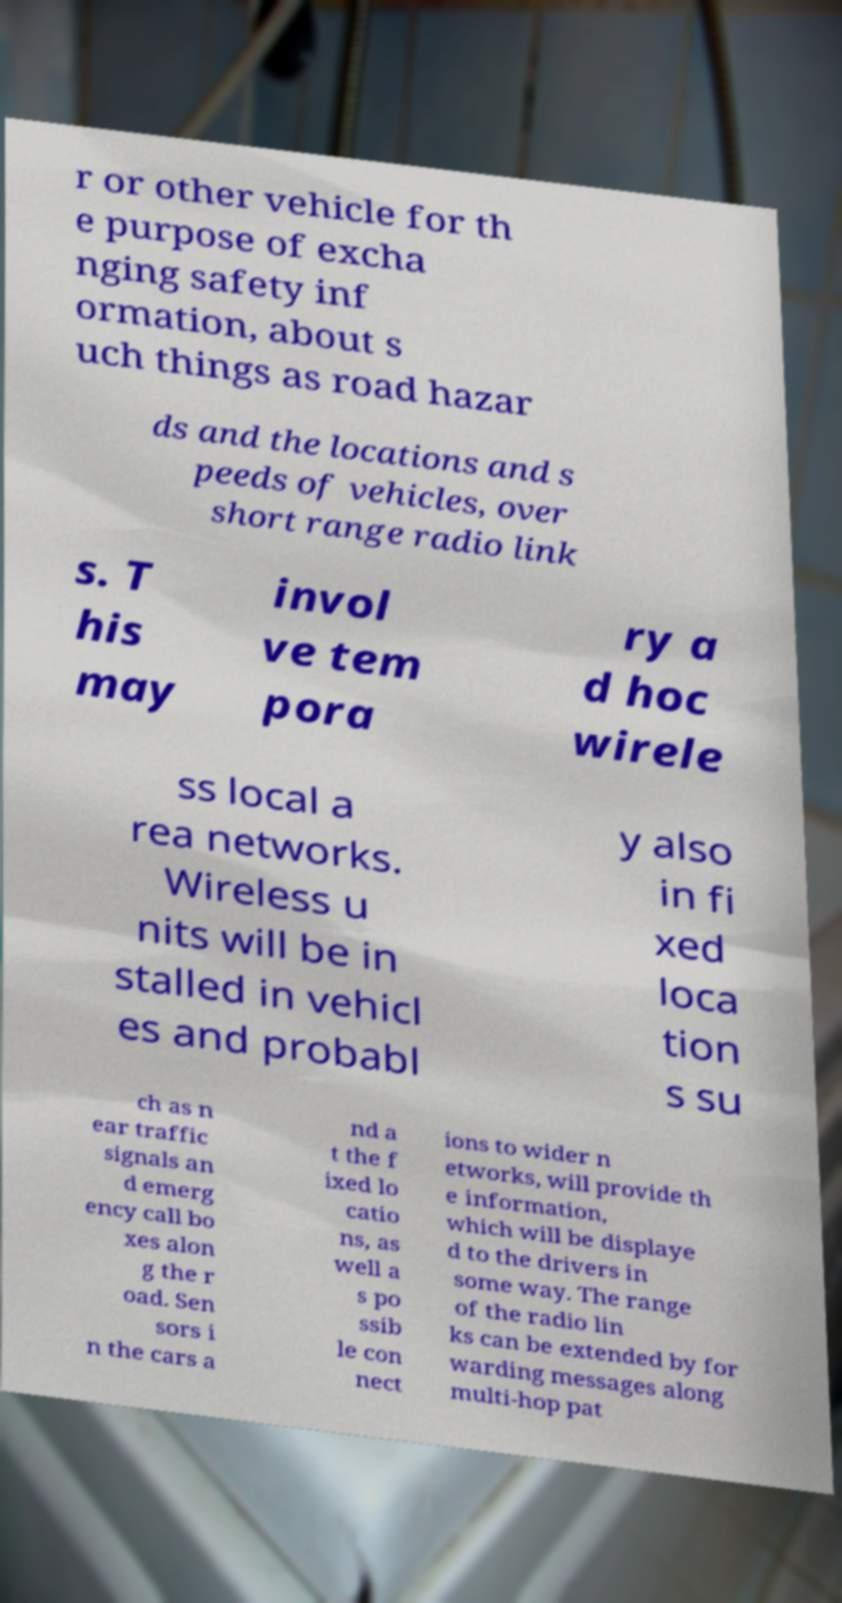I need the written content from this picture converted into text. Can you do that? r or other vehicle for th e purpose of excha nging safety inf ormation, about s uch things as road hazar ds and the locations and s peeds of vehicles, over short range radio link s. T his may invol ve tem pora ry a d hoc wirele ss local a rea networks. Wireless u nits will be in stalled in vehicl es and probabl y also in fi xed loca tion s su ch as n ear traffic signals an d emerg ency call bo xes alon g the r oad. Sen sors i n the cars a nd a t the f ixed lo catio ns, as well a s po ssib le con nect ions to wider n etworks, will provide th e information, which will be displaye d to the drivers in some way. The range of the radio lin ks can be extended by for warding messages along multi-hop pat 